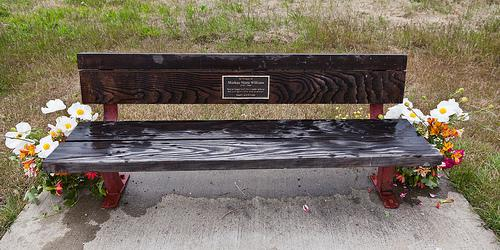Question: where is the bench?
Choices:
A. Street.
B. In a park.
C. Store.
D. Arena.
Answer with the letter. Answer: B Question: what color is the bench?
Choices:
A. Red.
B. Green.
C. Brown.
D. Black.
Answer with the letter. Answer: D 